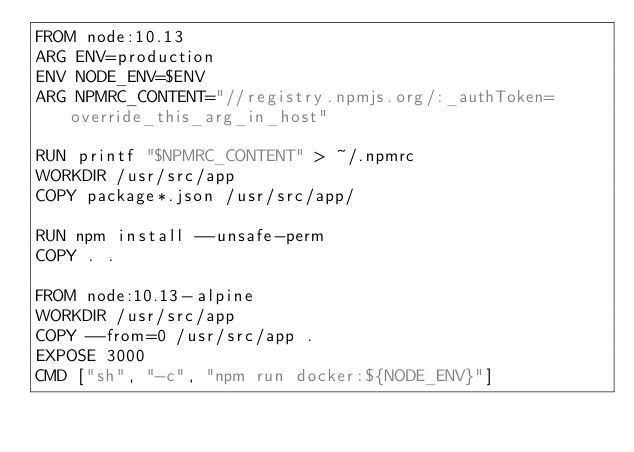Convert code to text. <code><loc_0><loc_0><loc_500><loc_500><_Dockerfile_>FROM node:10.13
ARG ENV=production
ENV NODE_ENV=$ENV
ARG NPMRC_CONTENT="//registry.npmjs.org/:_authToken=override_this_arg_in_host"

RUN printf "$NPMRC_CONTENT" > ~/.npmrc
WORKDIR /usr/src/app
COPY package*.json /usr/src/app/

RUN npm install --unsafe-perm
COPY . .

FROM node:10.13-alpine
WORKDIR /usr/src/app
COPY --from=0 /usr/src/app .
EXPOSE 3000
CMD ["sh", "-c", "npm run docker:${NODE_ENV}"]
</code> 